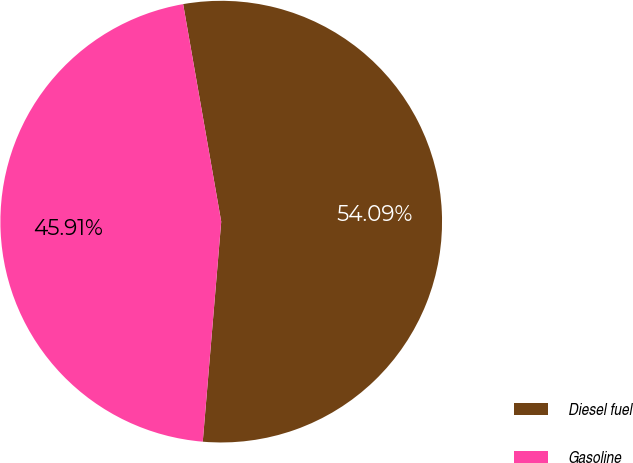Convert chart. <chart><loc_0><loc_0><loc_500><loc_500><pie_chart><fcel>Diesel fuel<fcel>Gasoline<nl><fcel>54.09%<fcel>45.91%<nl></chart> 